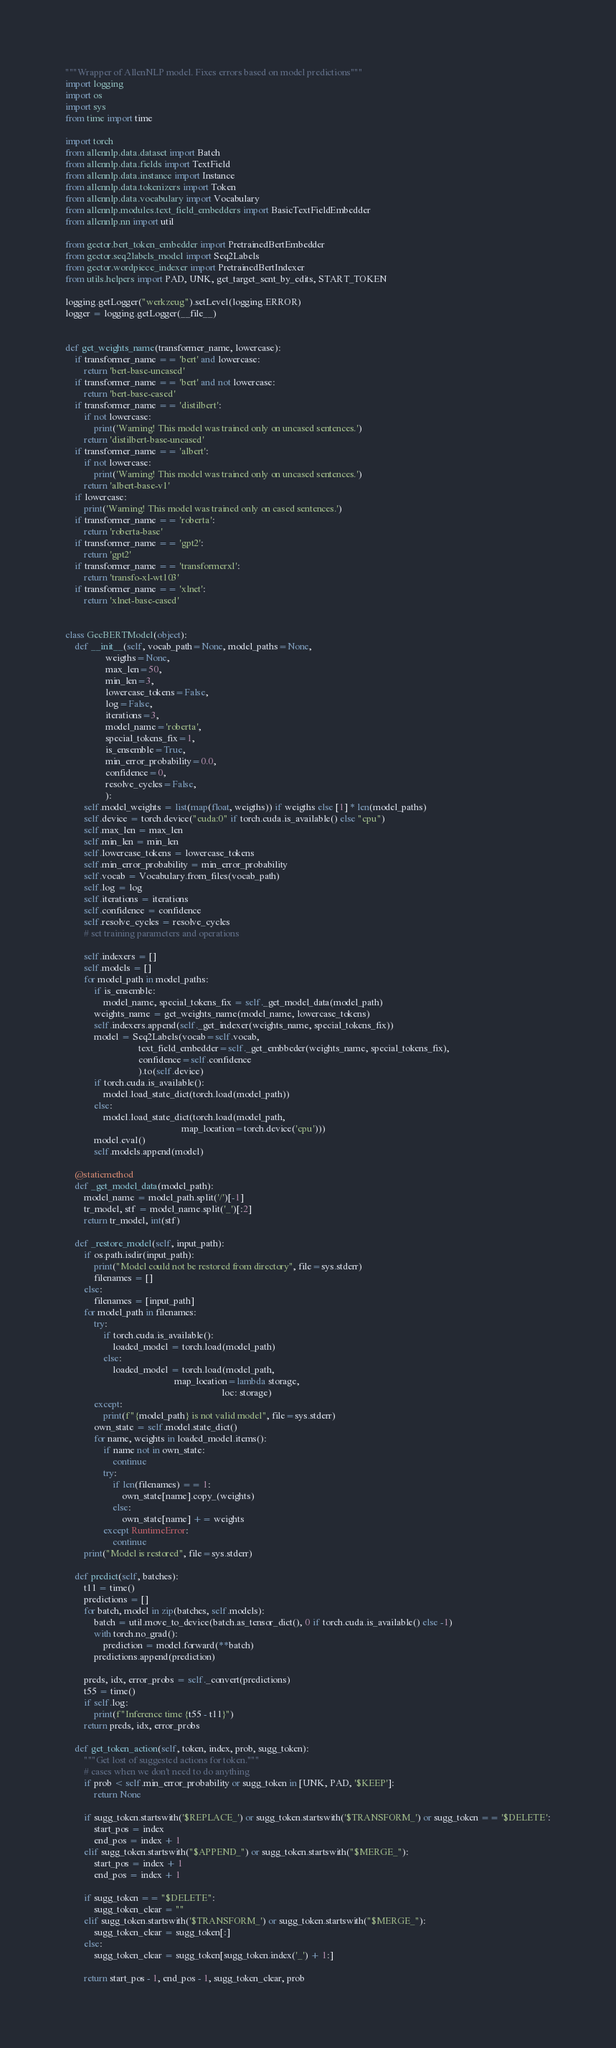Convert code to text. <code><loc_0><loc_0><loc_500><loc_500><_Python_>"""Wrapper of AllenNLP model. Fixes errors based on model predictions"""
import logging
import os
import sys
from time import time

import torch
from allennlp.data.dataset import Batch
from allennlp.data.fields import TextField
from allennlp.data.instance import Instance
from allennlp.data.tokenizers import Token
from allennlp.data.vocabulary import Vocabulary
from allennlp.modules.text_field_embedders import BasicTextFieldEmbedder
from allennlp.nn import util

from gector.bert_token_embedder import PretrainedBertEmbedder
from gector.seq2labels_model import Seq2Labels
from gector.wordpiece_indexer import PretrainedBertIndexer
from utils.helpers import PAD, UNK, get_target_sent_by_edits, START_TOKEN

logging.getLogger("werkzeug").setLevel(logging.ERROR)
logger = logging.getLogger(__file__)


def get_weights_name(transformer_name, lowercase):
    if transformer_name == 'bert' and lowercase:
        return 'bert-base-uncased'
    if transformer_name == 'bert' and not lowercase:
        return 'bert-base-cased'
    if transformer_name == 'distilbert':
        if not lowercase:
            print('Warning! This model was trained only on uncased sentences.')
        return 'distilbert-base-uncased'
    if transformer_name == 'albert':
        if not lowercase:
            print('Warning! This model was trained only on uncased sentences.')
        return 'albert-base-v1'
    if lowercase:
        print('Warning! This model was trained only on cased sentences.')
    if transformer_name == 'roberta':
        return 'roberta-base'
    if transformer_name == 'gpt2':
        return 'gpt2'
    if transformer_name == 'transformerxl':
        return 'transfo-xl-wt103'
    if transformer_name == 'xlnet':
        return 'xlnet-base-cased'


class GecBERTModel(object):
    def __init__(self, vocab_path=None, model_paths=None,
                 weigths=None,
                 max_len=50,
                 min_len=3,
                 lowercase_tokens=False,
                 log=False,
                 iterations=3,
                 model_name='roberta',
                 special_tokens_fix=1,
                 is_ensemble=True,
                 min_error_probability=0.0,
                 confidence=0,
                 resolve_cycles=False,
                 ):
        self.model_weights = list(map(float, weigths)) if weigths else [1] * len(model_paths)
        self.device = torch.device("cuda:0" if torch.cuda.is_available() else "cpu")
        self.max_len = max_len
        self.min_len = min_len
        self.lowercase_tokens = lowercase_tokens
        self.min_error_probability = min_error_probability
        self.vocab = Vocabulary.from_files(vocab_path)
        self.log = log
        self.iterations = iterations
        self.confidence = confidence
        self.resolve_cycles = resolve_cycles
        # set training parameters and operations

        self.indexers = []
        self.models = []
        for model_path in model_paths:
            if is_ensemble:
                model_name, special_tokens_fix = self._get_model_data(model_path)
            weights_name = get_weights_name(model_name, lowercase_tokens)
            self.indexers.append(self._get_indexer(weights_name, special_tokens_fix))
            model = Seq2Labels(vocab=self.vocab,
                               text_field_embedder=self._get_embbeder(weights_name, special_tokens_fix),
                               confidence=self.confidence
                               ).to(self.device)
            if torch.cuda.is_available():
                model.load_state_dict(torch.load(model_path))
            else:
                model.load_state_dict(torch.load(model_path,
                                                 map_location=torch.device('cpu')))
            model.eval()
            self.models.append(model)

    @staticmethod
    def _get_model_data(model_path):
        model_name = model_path.split('/')[-1]
        tr_model, stf = model_name.split('_')[:2]
        return tr_model, int(stf)

    def _restore_model(self, input_path):
        if os.path.isdir(input_path):
            print("Model could not be restored from directory", file=sys.stderr)
            filenames = []
        else:
            filenames = [input_path]
        for model_path in filenames:
            try:
                if torch.cuda.is_available():
                    loaded_model = torch.load(model_path)
                else:
                    loaded_model = torch.load(model_path,
                                              map_location=lambda storage,
                                                                  loc: storage)
            except:
                print(f"{model_path} is not valid model", file=sys.stderr)
            own_state = self.model.state_dict()
            for name, weights in loaded_model.items():
                if name not in own_state:
                    continue
                try:
                    if len(filenames) == 1:
                        own_state[name].copy_(weights)
                    else:
                        own_state[name] += weights
                except RuntimeError:
                    continue
        print("Model is restored", file=sys.stderr)

    def predict(self, batches):
        t11 = time()
        predictions = []
        for batch, model in zip(batches, self.models):
            batch = util.move_to_device(batch.as_tensor_dict(), 0 if torch.cuda.is_available() else -1)
            with torch.no_grad():
                prediction = model.forward(**batch)
            predictions.append(prediction)

        preds, idx, error_probs = self._convert(predictions)
        t55 = time()
        if self.log:
            print(f"Inference time {t55 - t11}")
        return preds, idx, error_probs

    def get_token_action(self, token, index, prob, sugg_token):
        """Get lost of suggested actions for token."""
        # cases when we don't need to do anything
        if prob < self.min_error_probability or sugg_token in [UNK, PAD, '$KEEP']:
            return None

        if sugg_token.startswith('$REPLACE_') or sugg_token.startswith('$TRANSFORM_') or sugg_token == '$DELETE':
            start_pos = index
            end_pos = index + 1
        elif sugg_token.startswith("$APPEND_") or sugg_token.startswith("$MERGE_"):
            start_pos = index + 1
            end_pos = index + 1

        if sugg_token == "$DELETE":
            sugg_token_clear = ""
        elif sugg_token.startswith('$TRANSFORM_') or sugg_token.startswith("$MERGE_"):
            sugg_token_clear = sugg_token[:]
        else:
            sugg_token_clear = sugg_token[sugg_token.index('_') + 1:]

        return start_pos - 1, end_pos - 1, sugg_token_clear, prob
</code> 